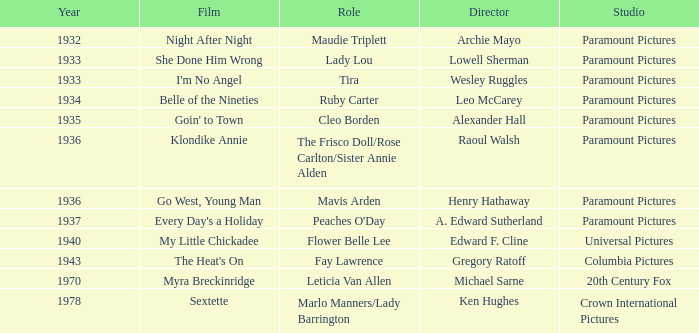What is the movie studio featuring director gregory ratoff following 1933? Columbia Pictures. 